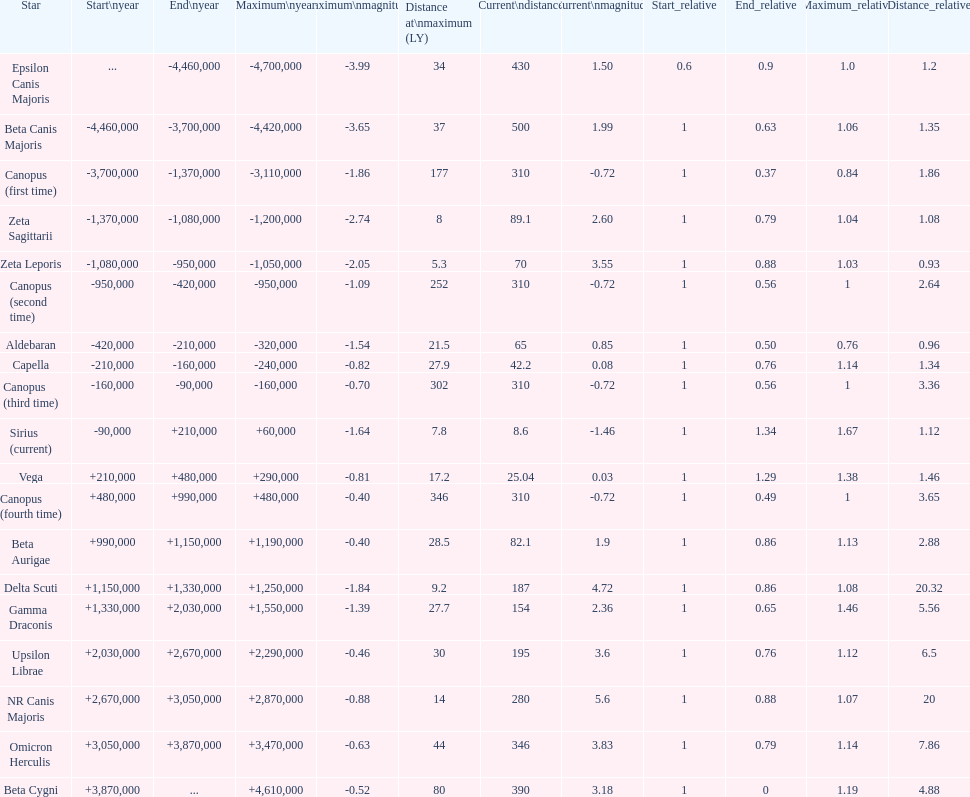Write the full table. {'header': ['Star', 'Start\\nyear', 'End\\nyear', 'Maximum\\nyear', 'Maximum\\nmagnitude', 'Distance at\\nmaximum (LY)', 'Current\\ndistance', 'Current\\nmagnitude', 'Start_relative', 'End_relative', 'Maximum_relative', 'Distance_relative'], 'rows': [['Epsilon Canis Majoris', '...', '-4,460,000', '-4,700,000', '-3.99', '34', '430', '1.50', '0.6', '0.9', '1.0', '1.2'], ['Beta Canis Majoris', '-4,460,000', '-3,700,000', '-4,420,000', '-3.65', '37', '500', '1.99', '1', '0.63', '1.06', '1.35'], ['Canopus (first time)', '-3,700,000', '-1,370,000', '-3,110,000', '-1.86', '177', '310', '-0.72', '1', '0.37', '0.84', '1.86'], ['Zeta Sagittarii', '-1,370,000', '-1,080,000', '-1,200,000', '-2.74', '8', '89.1', '2.60', '1', '0.79', '1.04', '1.08'], ['Zeta Leporis', '-1,080,000', '-950,000', '-1,050,000', '-2.05', '5.3', '70', '3.55', '1', '0.88', '1.03', '0.93'], ['Canopus (second time)', '-950,000', '-420,000', '-950,000', '-1.09', '252', '310', '-0.72', '1', '0.56', '1', '2.64'], ['Aldebaran', '-420,000', '-210,000', '-320,000', '-1.54', '21.5', '65', '0.85', '1', '0.50', '0.76', '0.96'], ['Capella', '-210,000', '-160,000', '-240,000', '-0.82', '27.9', '42.2', '0.08', '1', '0.76', '1.14', '1.34'], ['Canopus (third time)', '-160,000', '-90,000', '-160,000', '-0.70', '302', '310', '-0.72', '1', '0.56', '1', '3.36'], ['Sirius (current)', '-90,000', '+210,000', '+60,000', '-1.64', '7.8', '8.6', '-1.46', '1', '1.34', '1.67', '1.12'], ['Vega', '+210,000', '+480,000', '+290,000', '-0.81', '17.2', '25.04', '0.03', '1', '1.29', '1.38', '1.46'], ['Canopus (fourth time)', '+480,000', '+990,000', '+480,000', '-0.40', '346', '310', '-0.72', '1', '0.49', '1', '3.65'], ['Beta Aurigae', '+990,000', '+1,150,000', '+1,190,000', '-0.40', '28.5', '82.1', '1.9', '1', '0.86', '1.13', '2.88'], ['Delta Scuti', '+1,150,000', '+1,330,000', '+1,250,000', '-1.84', '9.2', '187', '4.72', '1', '0.86', '1.08', '20.32'], ['Gamma Draconis', '+1,330,000', '+2,030,000', '+1,550,000', '-1.39', '27.7', '154', '2.36', '1', '0.65', '1.46', '5.56'], ['Upsilon Librae', '+2,030,000', '+2,670,000', '+2,290,000', '-0.46', '30', '195', '3.6', '1', '0.76', '1.12', '6.5'], ['NR Canis Majoris', '+2,670,000', '+3,050,000', '+2,870,000', '-0.88', '14', '280', '5.6', '1', '0.88', '1.07', '20'], ['Omicron Herculis', '+3,050,000', '+3,870,000', '+3,470,000', '-0.63', '44', '346', '3.83', '1', '0.79', '1.14', '7.86'], ['Beta Cygni', '+3,870,000', '...', '+4,610,000', '-0.52', '80', '390', '3.18', '1', '0', '1.19', '4.88']]} What is the only star with a distance at maximum of 80? Beta Cygni. 